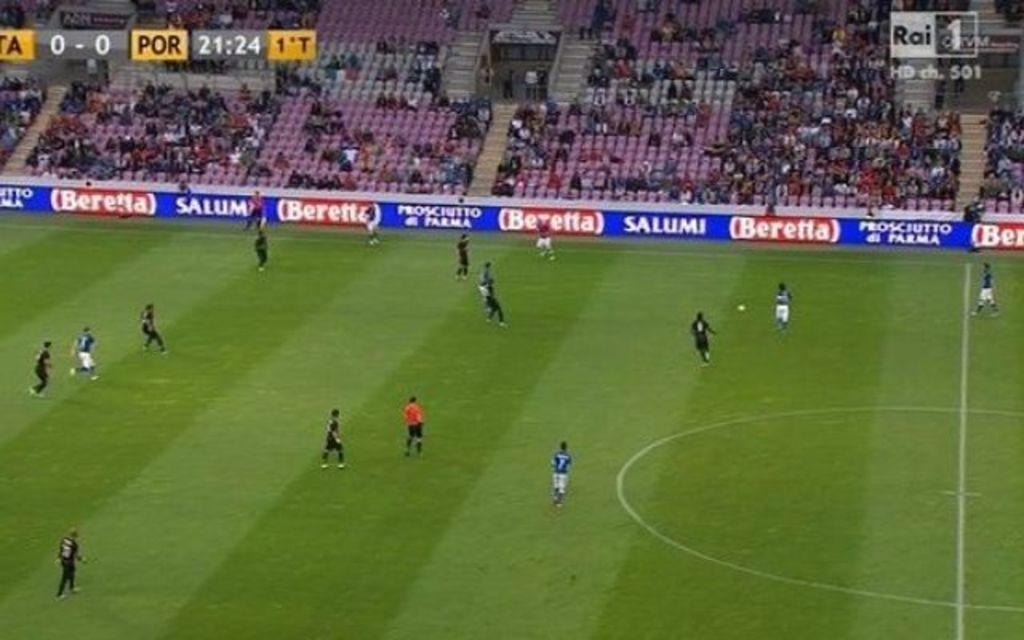Provide a one-sentence caption for the provided image. Two soccer teams are on a field with Beretta advertised on signage. 